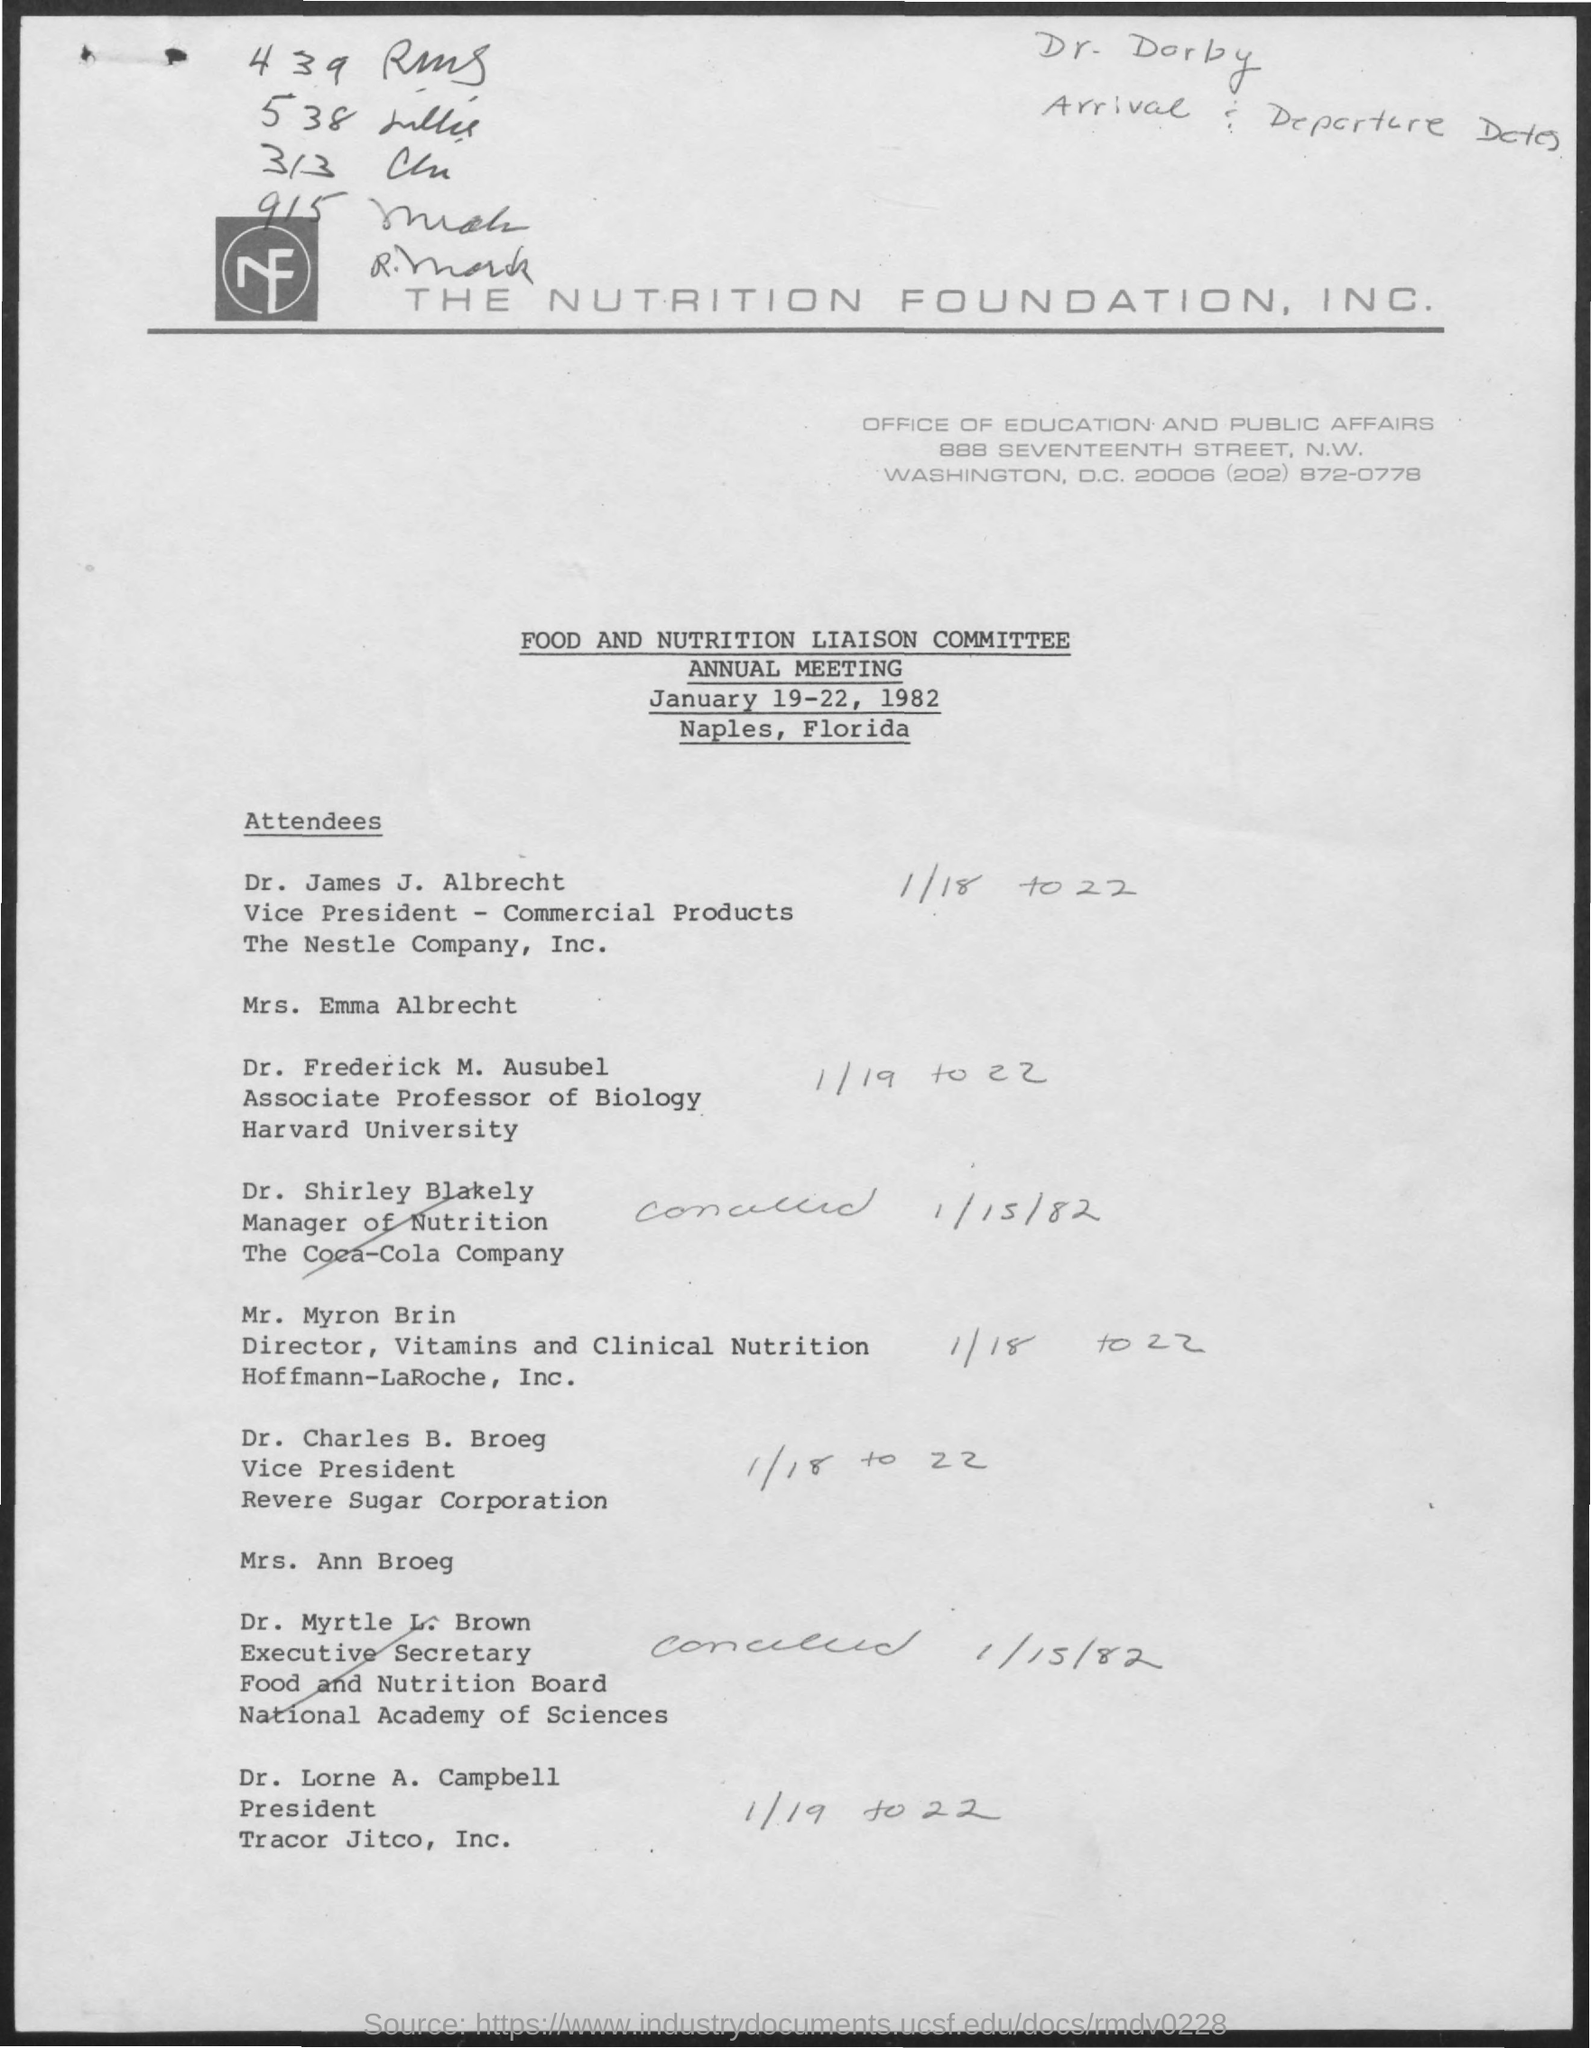Specify some key components in this picture. Frederick M. Ausubel is an associate professor who is affiliated with Harvard University. Charles B. Broeg is the vice-president of the Revere Sugar Corporation. It has been announced that Lorne A. Campbell is the current president of Tracor Jitco, Inc. The telephone number mentioned in the document is (202) 872-0778. 